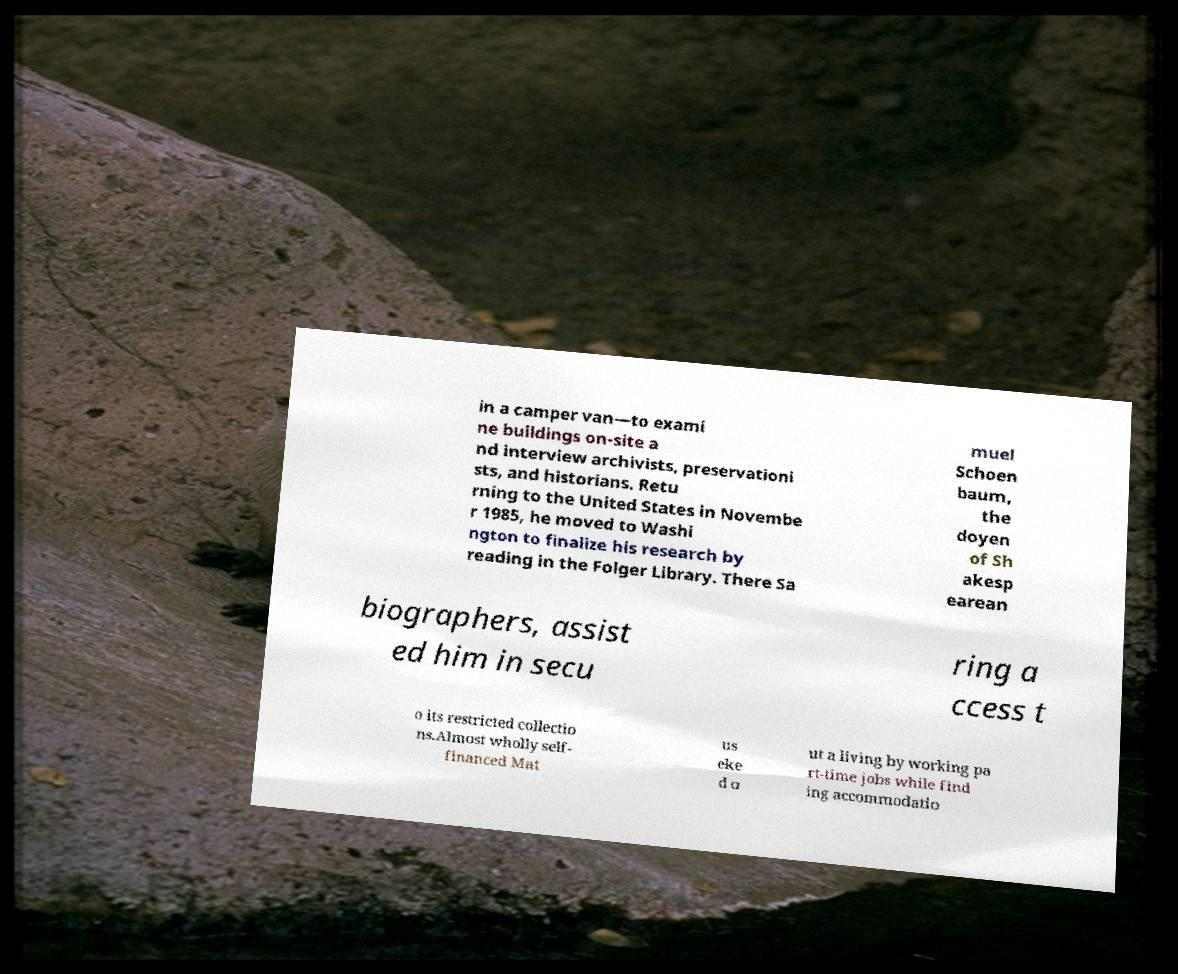Could you extract and type out the text from this image? in a camper van—to exami ne buildings on-site a nd interview archivists, preservationi sts, and historians. Retu rning to the United States in Novembe r 1985, he moved to Washi ngton to finalize his research by reading in the Folger Library. There Sa muel Schoen baum, the doyen of Sh akesp earean biographers, assist ed him in secu ring a ccess t o its restricted collectio ns.Almost wholly self- financed Mat us eke d o ut a living by working pa rt-time jobs while find ing accommodatio 